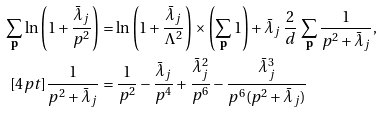<formula> <loc_0><loc_0><loc_500><loc_500>\sum _ { \mathbf p } \ln \left ( 1 + \frac { \bar { \lambda } _ { j } } { p ^ { 2 } } \right ) & = \ln \left ( 1 + \frac { \bar { \lambda } _ { j } } { \Lambda ^ { 2 } } \right ) \times \left ( \sum _ { \mathbf p } 1 \right ) + \bar { \lambda } _ { j } \, \frac { 2 } { d } \, \sum _ { \mathbf p } \frac { 1 } { p ^ { 2 } + \bar { \lambda } _ { j } } , \\ [ 4 p t ] \frac { 1 } { p ^ { 2 } + \bar { \lambda } _ { j } } & = \frac { 1 } { p ^ { 2 } } - \frac { \bar { \lambda } _ { j } } { p ^ { 4 } } + \frac { \bar { \lambda } _ { j } ^ { 2 } } { p ^ { 6 } } - \frac { \bar { \lambda } _ { j } ^ { 3 } } { p ^ { 6 } ( p ^ { 2 } + \bar { \lambda } _ { j } ) }</formula> 